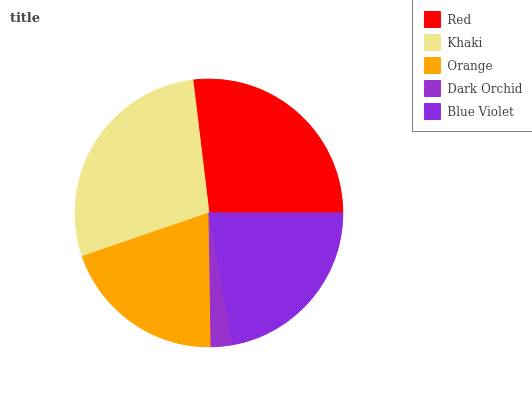Is Dark Orchid the minimum?
Answer yes or no. Yes. Is Khaki the maximum?
Answer yes or no. Yes. Is Orange the minimum?
Answer yes or no. No. Is Orange the maximum?
Answer yes or no. No. Is Khaki greater than Orange?
Answer yes or no. Yes. Is Orange less than Khaki?
Answer yes or no. Yes. Is Orange greater than Khaki?
Answer yes or no. No. Is Khaki less than Orange?
Answer yes or no. No. Is Blue Violet the high median?
Answer yes or no. Yes. Is Blue Violet the low median?
Answer yes or no. Yes. Is Khaki the high median?
Answer yes or no. No. Is Red the low median?
Answer yes or no. No. 